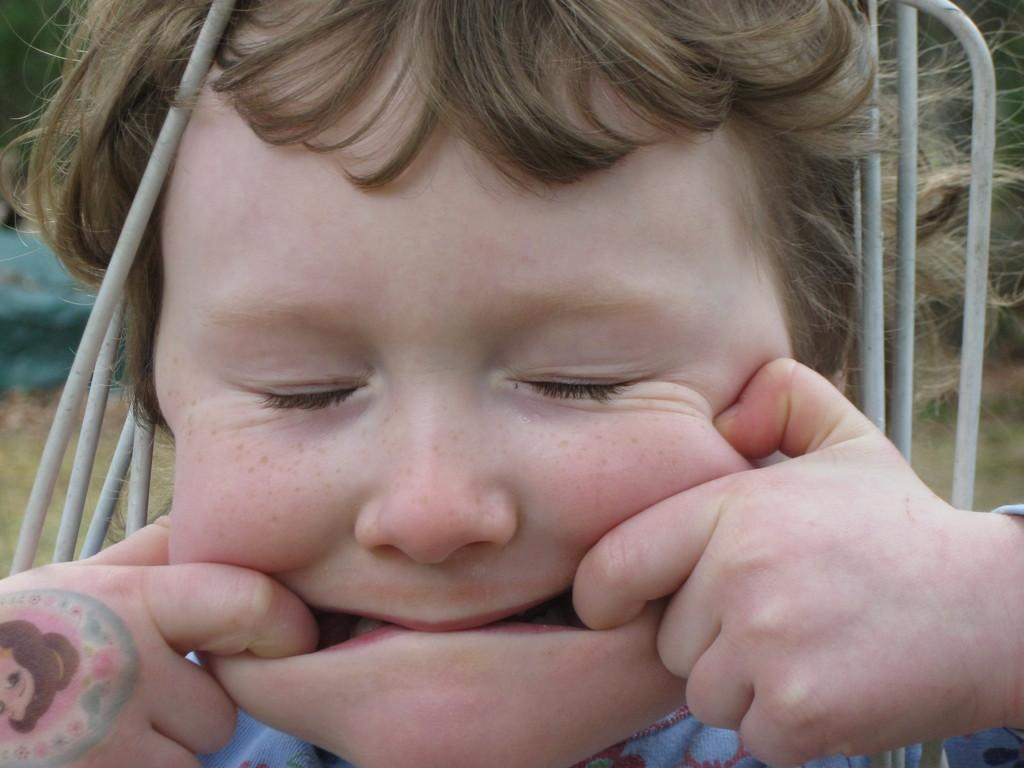What is the main subject in the foreground of the image? There is a boy in the foreground of the image. What objects can be seen in the image besides the boy? There are small pipes in the image. Can you describe the background of the image? The background of the image is blurry. What type of wool is being used to generate power in the image? There is no wool or power generation present in the image. 